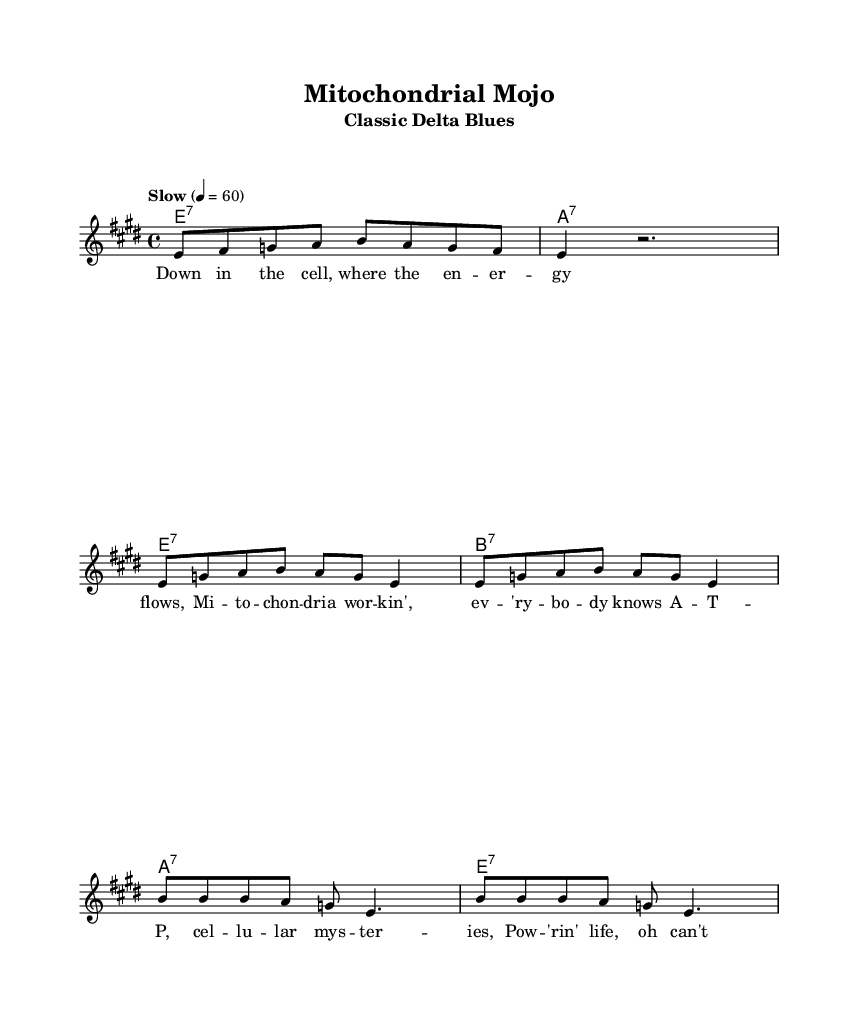What is the key signature of this music? The key signature is indicated at the start of the score. It shows two sharps, which represent F# and C#. This confirms that the key signature is E major.
Answer: E major What is the time signature of this music? The time signature is located right after the key signature. It is shown as 4/4, which means there are four beats in each measure and a quarter note gets one beat.
Answer: 4/4 What is the tempo marking for this piece? The tempo marking appears above the staff and indicates the speed of the music. It states "Slow" with a metronome marking of 60 beats per minute, meaning there are 60 beats in one minute.
Answer: Slow, 60 How many measures are in the chorus? The chorus is indicated by the section of music that follows the verse and is defined by its repeated structure. By counting the measures in the chorus section, we find there are two measures present.
Answer: 2 What is the seventh chord used in the harmonies? The harmonies are presented in a chord mode format, where "e1:7" indicates an E7 chord. This represents the tonic (I) in the key of E major.
Answer: E7 What type of lyrical structure is used in the verse? The verse follows a common blues lyrical structure that consists of four lines that describe a scenario, typically consisting of eight syllables each line. The structure is common to classic Delta blues.
Answer: Quatrain structure What cellular component is referenced in the lyrics? The lyrics mention "mitochondria," which are essential organelles known for their role in energy production within cells. This specifically ties the content of the blues to cellular energy processes.
Answer: Mitochondria 